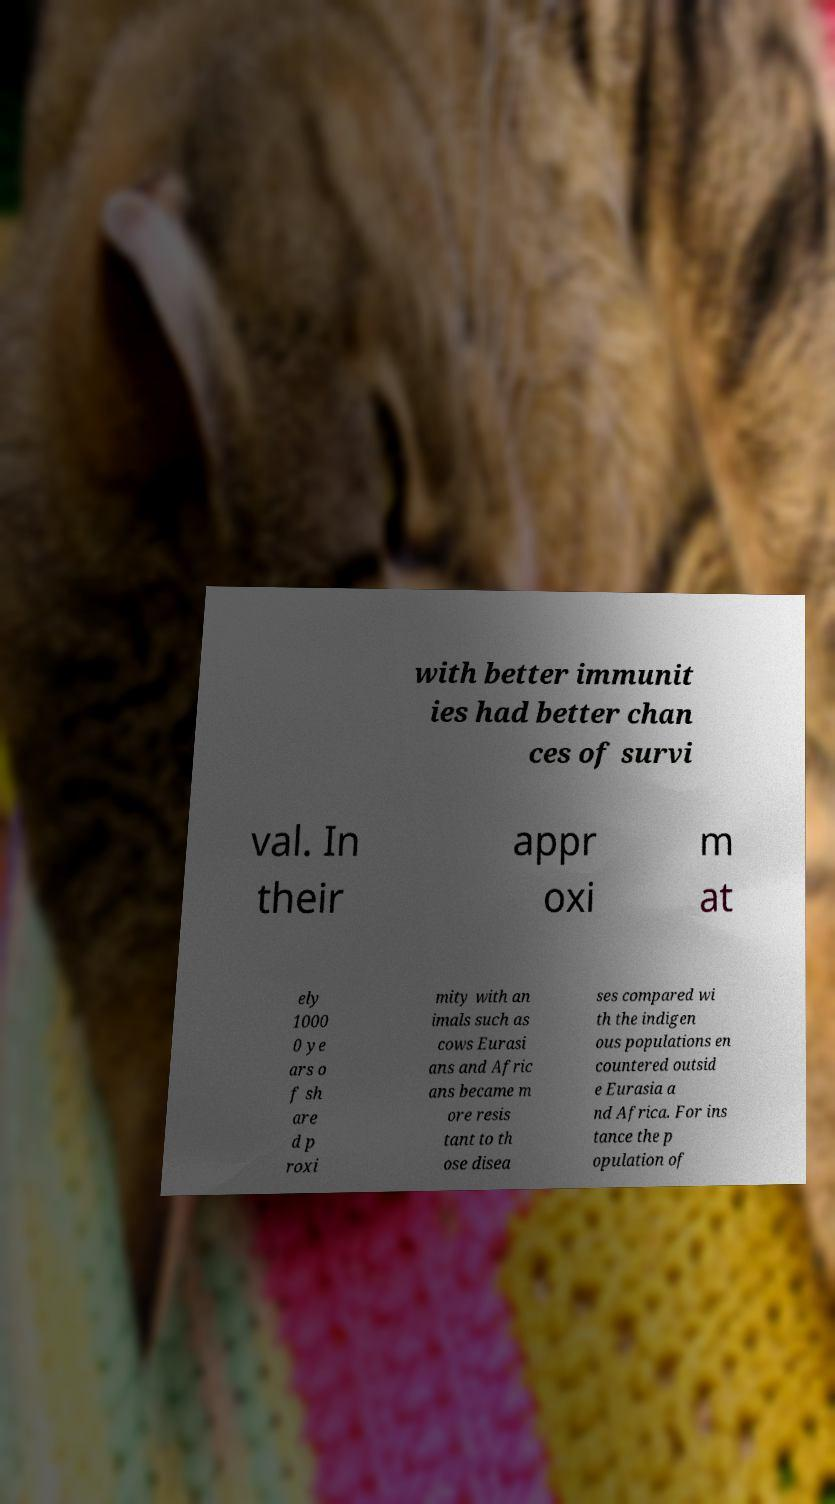Could you assist in decoding the text presented in this image and type it out clearly? with better immunit ies had better chan ces of survi val. In their appr oxi m at ely 1000 0 ye ars o f sh are d p roxi mity with an imals such as cows Eurasi ans and Afric ans became m ore resis tant to th ose disea ses compared wi th the indigen ous populations en countered outsid e Eurasia a nd Africa. For ins tance the p opulation of 